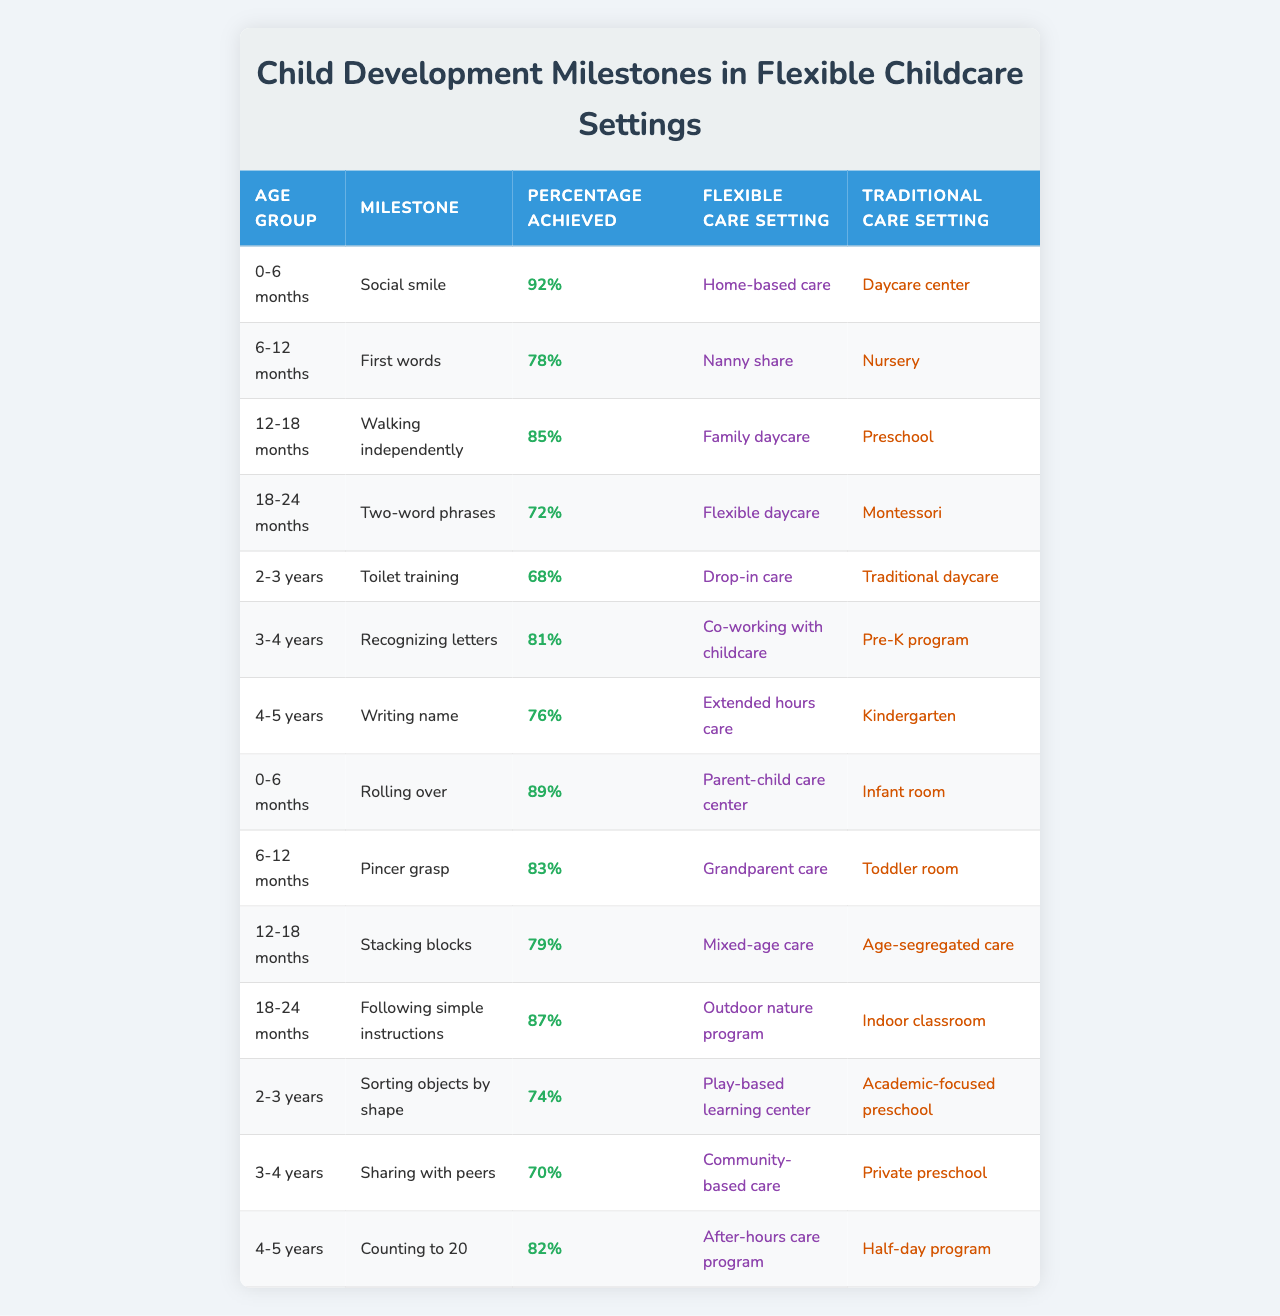What percentage of children aged 6-12 months achieve their first words in a flexible care setting? According to the table, 78% of children aged 6-12 months achieve their first words in a nanny share, which is categorized as a flexible care setting.
Answer: 78% Which milestone has the highest percentage achieved in a flexible care setting for the age group 0-6 months? The milestone with the highest percentage for the 0-6 months age group is the social smile, achieved at 92% in a home-based care setting.
Answer: Social smile Is the percentage of children achieving the milestone of writing their name higher in traditional or flexible care settings? In the table, 76% of children achieve the milestone of writing their name in extended hours care (flexible) and 76% in kindergarten (traditional). Both settings show the same percentage.
Answer: No difference What is the difference in the percentage of children who can sort objects by shape between the two childcare settings for the 2-3 years age group? In a play-based learning center (flexible), the percentage is 74%, and in an academic-focused preschool (traditional), it is 74%. Therefore, there is no difference between the two settings for this milestone.
Answer: 0% Which flexible care setting has the highest percentage achievement for the milestone of following simple instructions in the 18-24 months age group? The flexible care setting with the highest percentage at 87% for the milestone of following simple instructions is the outdoor nature program.
Answer: Outdoor nature program Across all age groups, what is the average percentage of milestones achieved in flexible care settings? To find the average, we sum all percentages for flexible care settings and divide by the total number of entries. Summing the percentages: 92 + 78 + 85 + 72 + 68 + 81 + 76 + 89 + 83 + 79 + 87 + 74 + 70 + 82 = 1067. There are 14 entries, so the average is 1067 / 14 ≈ 76.14.
Answer: 76.14% In terms of language development, which age group shows the lowest achievement in a flexible care setting? Reviewing the table, the age group of 2-3 years shows the lowest percentage for the milestone of toilet training, which is 68%.
Answer: 2-3 years Is there a trend showing that younger age groups tend to achieve milestones at higher percentages compared to older groups in flexible care settings? Upon examining the data, younger age groups like 0-6 months and 6-12 months have higher achievement percentages while older groups like 2-3 years and 3-4 years show comparatively lower percentages, indicating a trend where younger age groups achieve milestones at higher rates.
Answer: Yes What percentage of children achieve the ability to count to 20 in a flexible care setting and how does it compare to traditional care settings? In a flexible care setting, 82% achieve counting to 20, while the traditional care setting (half-day program) has the same percentage. Thus, they are equal.
Answer: 82% (equal) 